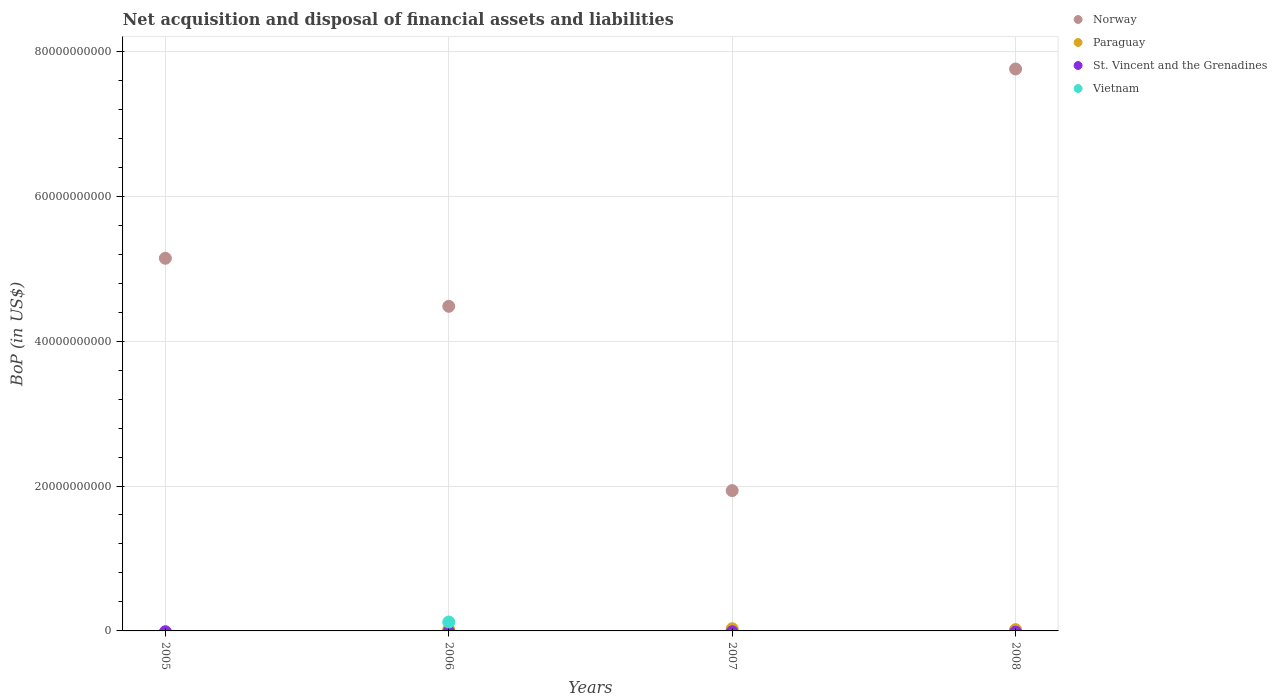How many different coloured dotlines are there?
Ensure brevity in your answer.  3. Is the number of dotlines equal to the number of legend labels?
Give a very brief answer. No. What is the Balance of Payments in Norway in 2007?
Give a very brief answer. 1.94e+1. Across all years, what is the maximum Balance of Payments in Vietnam?
Give a very brief answer. 1.23e+09. What is the difference between the Balance of Payments in Norway in 2006 and that in 2008?
Give a very brief answer. -3.28e+1. What is the difference between the Balance of Payments in Vietnam in 2007 and the Balance of Payments in Norway in 2008?
Provide a succinct answer. -7.76e+1. What is the average Balance of Payments in Vietnam per year?
Provide a short and direct response. 3.08e+08. In the year 2006, what is the difference between the Balance of Payments in Paraguay and Balance of Payments in Norway?
Make the answer very short. -4.46e+1. In how many years, is the Balance of Payments in Paraguay greater than 52000000000 US$?
Offer a terse response. 0. What is the ratio of the Balance of Payments in Norway in 2006 to that in 2008?
Your answer should be compact. 0.58. What is the difference between the highest and the second highest Balance of Payments in Norway?
Ensure brevity in your answer.  2.61e+1. What is the difference between the highest and the lowest Balance of Payments in Norway?
Ensure brevity in your answer.  5.82e+1. In how many years, is the Balance of Payments in Paraguay greater than the average Balance of Payments in Paraguay taken over all years?
Your answer should be very brief. 3. Is the sum of the Balance of Payments in Paraguay in 2006 and 2007 greater than the maximum Balance of Payments in Vietnam across all years?
Ensure brevity in your answer.  No. Is it the case that in every year, the sum of the Balance of Payments in Norway and Balance of Payments in St. Vincent and the Grenadines  is greater than the sum of Balance of Payments in Vietnam and Balance of Payments in Paraguay?
Offer a terse response. No. Is it the case that in every year, the sum of the Balance of Payments in St. Vincent and the Grenadines and Balance of Payments in Norway  is greater than the Balance of Payments in Paraguay?
Keep it short and to the point. Yes. Does the Balance of Payments in St. Vincent and the Grenadines monotonically increase over the years?
Your answer should be compact. No. How many dotlines are there?
Provide a short and direct response. 3. How many years are there in the graph?
Your answer should be compact. 4. What is the difference between two consecutive major ticks on the Y-axis?
Keep it short and to the point. 2.00e+1. Does the graph contain any zero values?
Offer a terse response. Yes. Where does the legend appear in the graph?
Offer a terse response. Top right. What is the title of the graph?
Keep it short and to the point. Net acquisition and disposal of financial assets and liabilities. Does "Ireland" appear as one of the legend labels in the graph?
Your answer should be compact. No. What is the label or title of the X-axis?
Offer a very short reply. Years. What is the label or title of the Y-axis?
Ensure brevity in your answer.  BoP (in US$). What is the BoP (in US$) of Norway in 2005?
Offer a very short reply. 5.14e+1. What is the BoP (in US$) of St. Vincent and the Grenadines in 2005?
Provide a short and direct response. 0. What is the BoP (in US$) in Vietnam in 2005?
Your answer should be compact. 0. What is the BoP (in US$) of Norway in 2006?
Offer a terse response. 4.48e+1. What is the BoP (in US$) in Paraguay in 2006?
Keep it short and to the point. 2.02e+08. What is the BoP (in US$) of St. Vincent and the Grenadines in 2006?
Your answer should be very brief. 0. What is the BoP (in US$) of Vietnam in 2006?
Keep it short and to the point. 1.23e+09. What is the BoP (in US$) in Norway in 2007?
Offer a terse response. 1.94e+1. What is the BoP (in US$) of Paraguay in 2007?
Your response must be concise. 3.02e+08. What is the BoP (in US$) in St. Vincent and the Grenadines in 2007?
Your response must be concise. 0. What is the BoP (in US$) in Vietnam in 2007?
Offer a very short reply. 0. What is the BoP (in US$) in Norway in 2008?
Offer a very short reply. 7.76e+1. What is the BoP (in US$) of Paraguay in 2008?
Your answer should be compact. 1.76e+08. What is the BoP (in US$) of St. Vincent and the Grenadines in 2008?
Your response must be concise. 0. Across all years, what is the maximum BoP (in US$) in Norway?
Make the answer very short. 7.76e+1. Across all years, what is the maximum BoP (in US$) in Paraguay?
Provide a short and direct response. 3.02e+08. Across all years, what is the maximum BoP (in US$) of Vietnam?
Provide a short and direct response. 1.23e+09. Across all years, what is the minimum BoP (in US$) of Norway?
Your answer should be very brief. 1.94e+1. What is the total BoP (in US$) in Norway in the graph?
Your answer should be compact. 1.93e+11. What is the total BoP (in US$) in Paraguay in the graph?
Provide a succinct answer. 6.79e+08. What is the total BoP (in US$) in St. Vincent and the Grenadines in the graph?
Keep it short and to the point. 0. What is the total BoP (in US$) in Vietnam in the graph?
Ensure brevity in your answer.  1.23e+09. What is the difference between the BoP (in US$) of Norway in 2005 and that in 2006?
Make the answer very short. 6.63e+09. What is the difference between the BoP (in US$) of Norway in 2005 and that in 2007?
Your answer should be very brief. 3.21e+1. What is the difference between the BoP (in US$) in Norway in 2005 and that in 2008?
Provide a succinct answer. -2.61e+1. What is the difference between the BoP (in US$) of Norway in 2006 and that in 2007?
Your response must be concise. 2.54e+1. What is the difference between the BoP (in US$) of Paraguay in 2006 and that in 2007?
Ensure brevity in your answer.  -1.00e+08. What is the difference between the BoP (in US$) in Norway in 2006 and that in 2008?
Make the answer very short. -3.28e+1. What is the difference between the BoP (in US$) in Paraguay in 2006 and that in 2008?
Provide a short and direct response. 2.55e+07. What is the difference between the BoP (in US$) of Norway in 2007 and that in 2008?
Your answer should be compact. -5.82e+1. What is the difference between the BoP (in US$) of Paraguay in 2007 and that in 2008?
Your answer should be compact. 1.26e+08. What is the difference between the BoP (in US$) in Norway in 2005 and the BoP (in US$) in Paraguay in 2006?
Ensure brevity in your answer.  5.12e+1. What is the difference between the BoP (in US$) in Norway in 2005 and the BoP (in US$) in Vietnam in 2006?
Your response must be concise. 5.02e+1. What is the difference between the BoP (in US$) of Norway in 2005 and the BoP (in US$) of Paraguay in 2007?
Your response must be concise. 5.11e+1. What is the difference between the BoP (in US$) of Norway in 2005 and the BoP (in US$) of Paraguay in 2008?
Keep it short and to the point. 5.13e+1. What is the difference between the BoP (in US$) of Norway in 2006 and the BoP (in US$) of Paraguay in 2007?
Give a very brief answer. 4.45e+1. What is the difference between the BoP (in US$) in Norway in 2006 and the BoP (in US$) in Paraguay in 2008?
Make the answer very short. 4.46e+1. What is the difference between the BoP (in US$) in Norway in 2007 and the BoP (in US$) in Paraguay in 2008?
Your response must be concise. 1.92e+1. What is the average BoP (in US$) of Norway per year?
Your answer should be very brief. 4.83e+1. What is the average BoP (in US$) in Paraguay per year?
Your answer should be compact. 1.70e+08. What is the average BoP (in US$) in St. Vincent and the Grenadines per year?
Give a very brief answer. 0. What is the average BoP (in US$) in Vietnam per year?
Your response must be concise. 3.08e+08. In the year 2006, what is the difference between the BoP (in US$) of Norway and BoP (in US$) of Paraguay?
Your response must be concise. 4.46e+1. In the year 2006, what is the difference between the BoP (in US$) in Norway and BoP (in US$) in Vietnam?
Your response must be concise. 4.36e+1. In the year 2006, what is the difference between the BoP (in US$) in Paraguay and BoP (in US$) in Vietnam?
Offer a terse response. -1.03e+09. In the year 2007, what is the difference between the BoP (in US$) in Norway and BoP (in US$) in Paraguay?
Offer a very short reply. 1.91e+1. In the year 2008, what is the difference between the BoP (in US$) of Norway and BoP (in US$) of Paraguay?
Offer a terse response. 7.74e+1. What is the ratio of the BoP (in US$) in Norway in 2005 to that in 2006?
Offer a terse response. 1.15. What is the ratio of the BoP (in US$) of Norway in 2005 to that in 2007?
Provide a succinct answer. 2.66. What is the ratio of the BoP (in US$) of Norway in 2005 to that in 2008?
Offer a terse response. 0.66. What is the ratio of the BoP (in US$) in Norway in 2006 to that in 2007?
Provide a succinct answer. 2.31. What is the ratio of the BoP (in US$) of Paraguay in 2006 to that in 2007?
Keep it short and to the point. 0.67. What is the ratio of the BoP (in US$) in Norway in 2006 to that in 2008?
Provide a short and direct response. 0.58. What is the ratio of the BoP (in US$) in Paraguay in 2006 to that in 2008?
Your answer should be compact. 1.15. What is the ratio of the BoP (in US$) in Norway in 2007 to that in 2008?
Offer a very short reply. 0.25. What is the ratio of the BoP (in US$) in Paraguay in 2007 to that in 2008?
Your response must be concise. 1.71. What is the difference between the highest and the second highest BoP (in US$) in Norway?
Provide a short and direct response. 2.61e+1. What is the difference between the highest and the second highest BoP (in US$) in Paraguay?
Ensure brevity in your answer.  1.00e+08. What is the difference between the highest and the lowest BoP (in US$) in Norway?
Offer a terse response. 5.82e+1. What is the difference between the highest and the lowest BoP (in US$) in Paraguay?
Offer a terse response. 3.02e+08. What is the difference between the highest and the lowest BoP (in US$) in Vietnam?
Provide a short and direct response. 1.23e+09. 